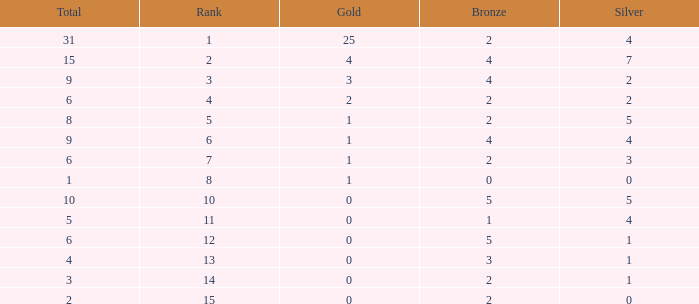What is the highest rank of the medal total less than 15, more than 2 bronzes, 0 gold and 1 silver? 13.0. 